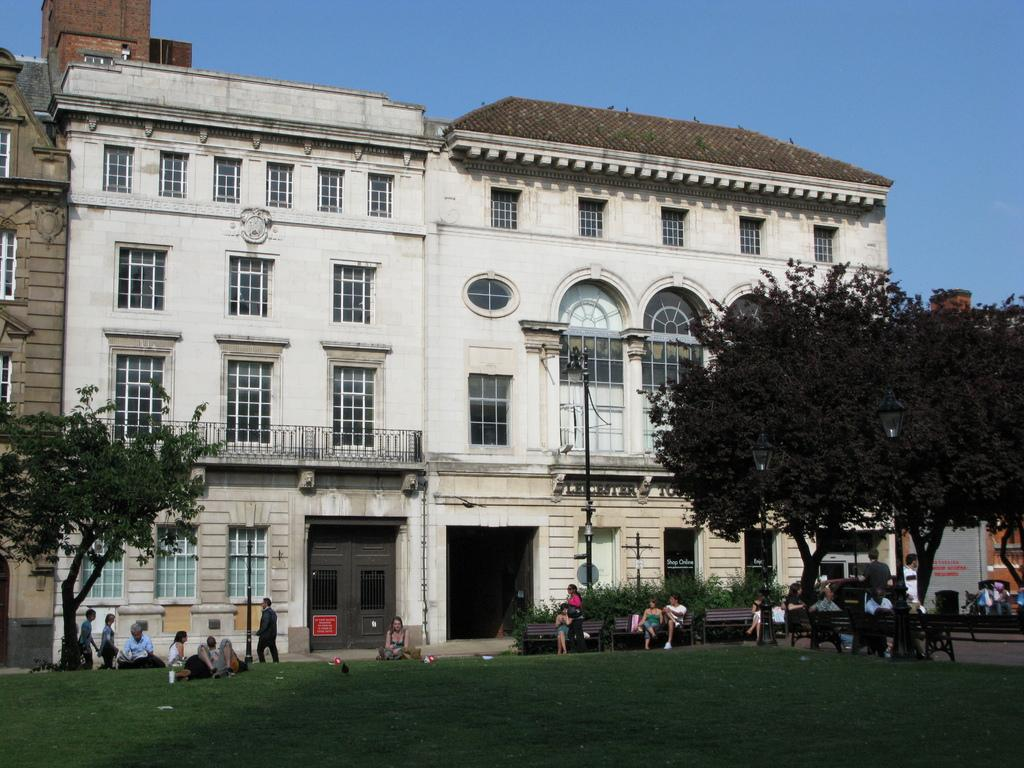How many people are in the image? There are persons in the image, but the exact number cannot be determined from the provided facts. What type of natural environment is visible in the image? There is grass, trees, and plants visible in the image. What type of structures are present in the image? There are poles, boards, benches, doors, windows, and buildings in the image. What is visible in the background of the image? The sky is visible in the background of the image. Where is the sofa located in the image? There is no sofa present in the image. What type of field can be seen in the image? There is no field visible in the image. 